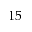Convert formula to latex. <formula><loc_0><loc_0><loc_500><loc_500>1 5</formula> 